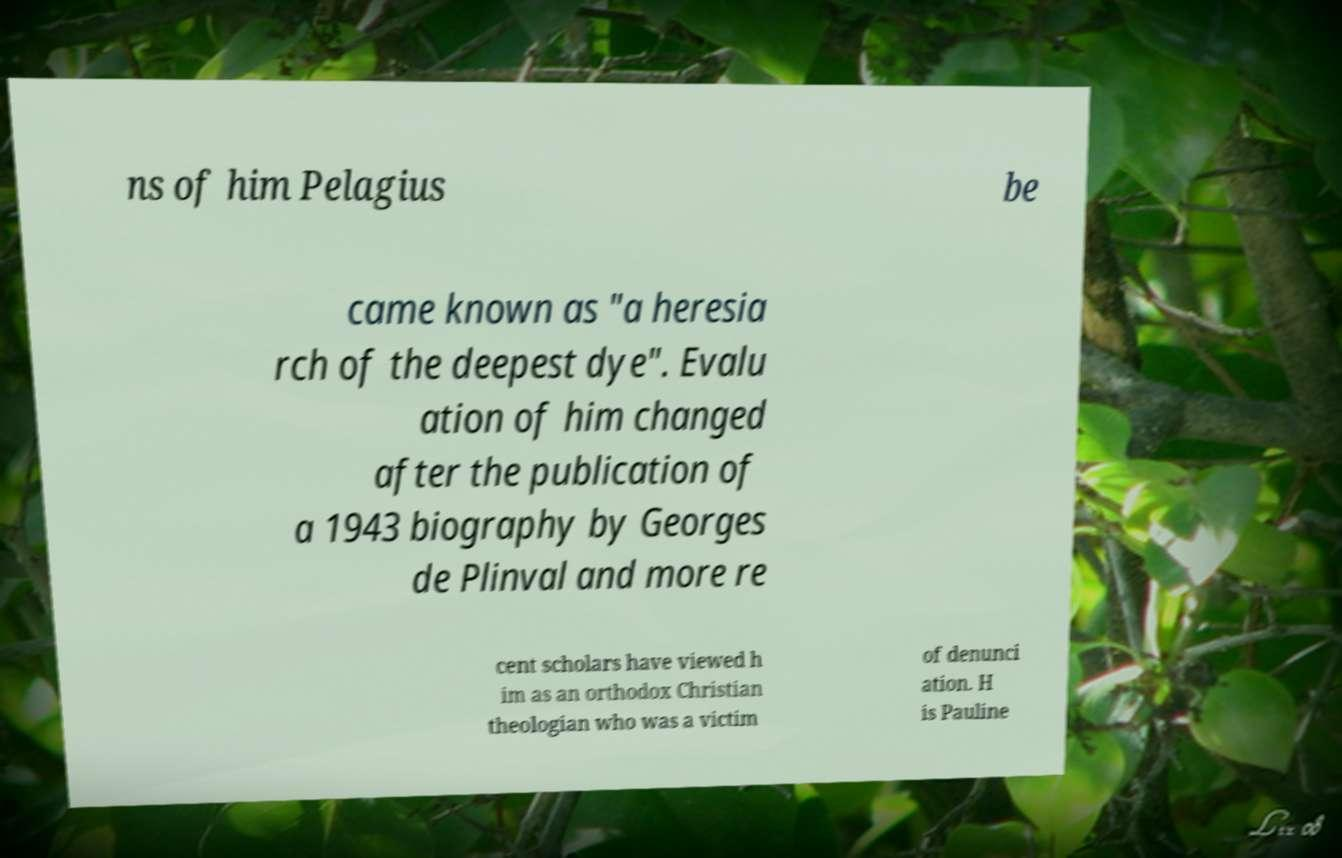Can you read and provide the text displayed in the image?This photo seems to have some interesting text. Can you extract and type it out for me? ns of him Pelagius be came known as "a heresia rch of the deepest dye". Evalu ation of him changed after the publication of a 1943 biography by Georges de Plinval and more re cent scholars have viewed h im as an orthodox Christian theologian who was a victim of denunci ation. H is Pauline 